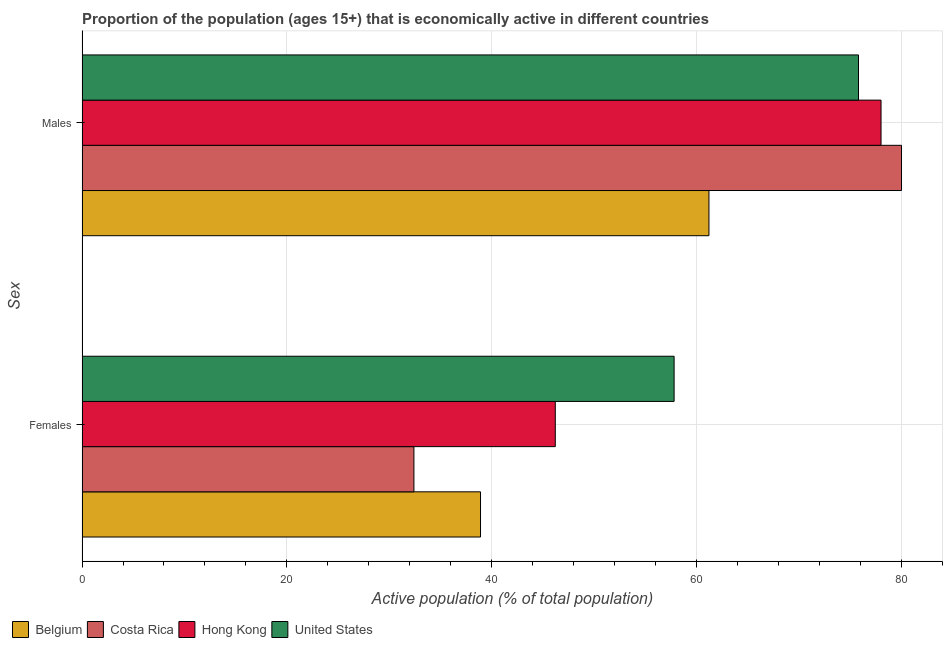How many bars are there on the 2nd tick from the top?
Provide a succinct answer. 4. What is the label of the 1st group of bars from the top?
Offer a terse response. Males. What is the percentage of economically active female population in Belgium?
Your answer should be compact. 38.9. Across all countries, what is the maximum percentage of economically active female population?
Your response must be concise. 57.8. Across all countries, what is the minimum percentage of economically active male population?
Your answer should be very brief. 61.2. What is the total percentage of economically active male population in the graph?
Offer a terse response. 295. What is the difference between the percentage of economically active female population in Hong Kong and that in United States?
Provide a short and direct response. -11.6. What is the difference between the percentage of economically active male population in Belgium and the percentage of economically active female population in Costa Rica?
Ensure brevity in your answer.  28.8. What is the average percentage of economically active male population per country?
Your answer should be very brief. 73.75. What is the difference between the percentage of economically active female population and percentage of economically active male population in Costa Rica?
Your answer should be very brief. -47.6. In how many countries, is the percentage of economically active male population greater than 24 %?
Ensure brevity in your answer.  4. What is the ratio of the percentage of economically active female population in Costa Rica to that in Belgium?
Give a very brief answer. 0.83. In how many countries, is the percentage of economically active male population greater than the average percentage of economically active male population taken over all countries?
Provide a succinct answer. 3. What does the 2nd bar from the top in Males represents?
Offer a terse response. Hong Kong. How many countries are there in the graph?
Make the answer very short. 4. What is the difference between two consecutive major ticks on the X-axis?
Provide a short and direct response. 20. Are the values on the major ticks of X-axis written in scientific E-notation?
Offer a very short reply. No. Does the graph contain grids?
Make the answer very short. Yes. Where does the legend appear in the graph?
Provide a succinct answer. Bottom left. How are the legend labels stacked?
Give a very brief answer. Horizontal. What is the title of the graph?
Provide a succinct answer. Proportion of the population (ages 15+) that is economically active in different countries. What is the label or title of the X-axis?
Offer a very short reply. Active population (% of total population). What is the label or title of the Y-axis?
Give a very brief answer. Sex. What is the Active population (% of total population) in Belgium in Females?
Offer a terse response. 38.9. What is the Active population (% of total population) in Costa Rica in Females?
Provide a short and direct response. 32.4. What is the Active population (% of total population) of Hong Kong in Females?
Your response must be concise. 46.2. What is the Active population (% of total population) of United States in Females?
Keep it short and to the point. 57.8. What is the Active population (% of total population) of Belgium in Males?
Your answer should be very brief. 61.2. What is the Active population (% of total population) of United States in Males?
Offer a very short reply. 75.8. Across all Sex, what is the maximum Active population (% of total population) in Belgium?
Offer a very short reply. 61.2. Across all Sex, what is the maximum Active population (% of total population) of Costa Rica?
Your answer should be compact. 80. Across all Sex, what is the maximum Active population (% of total population) in Hong Kong?
Your response must be concise. 78. Across all Sex, what is the maximum Active population (% of total population) in United States?
Provide a succinct answer. 75.8. Across all Sex, what is the minimum Active population (% of total population) in Belgium?
Give a very brief answer. 38.9. Across all Sex, what is the minimum Active population (% of total population) of Costa Rica?
Offer a very short reply. 32.4. Across all Sex, what is the minimum Active population (% of total population) of Hong Kong?
Your answer should be compact. 46.2. Across all Sex, what is the minimum Active population (% of total population) of United States?
Keep it short and to the point. 57.8. What is the total Active population (% of total population) of Belgium in the graph?
Provide a short and direct response. 100.1. What is the total Active population (% of total population) in Costa Rica in the graph?
Offer a terse response. 112.4. What is the total Active population (% of total population) of Hong Kong in the graph?
Make the answer very short. 124.2. What is the total Active population (% of total population) in United States in the graph?
Provide a short and direct response. 133.6. What is the difference between the Active population (% of total population) of Belgium in Females and that in Males?
Your response must be concise. -22.3. What is the difference between the Active population (% of total population) in Costa Rica in Females and that in Males?
Ensure brevity in your answer.  -47.6. What is the difference between the Active population (% of total population) of Hong Kong in Females and that in Males?
Offer a very short reply. -31.8. What is the difference between the Active population (% of total population) in Belgium in Females and the Active population (% of total population) in Costa Rica in Males?
Your answer should be compact. -41.1. What is the difference between the Active population (% of total population) of Belgium in Females and the Active population (% of total population) of Hong Kong in Males?
Make the answer very short. -39.1. What is the difference between the Active population (% of total population) of Belgium in Females and the Active population (% of total population) of United States in Males?
Your response must be concise. -36.9. What is the difference between the Active population (% of total population) in Costa Rica in Females and the Active population (% of total population) in Hong Kong in Males?
Provide a short and direct response. -45.6. What is the difference between the Active population (% of total population) in Costa Rica in Females and the Active population (% of total population) in United States in Males?
Offer a terse response. -43.4. What is the difference between the Active population (% of total population) of Hong Kong in Females and the Active population (% of total population) of United States in Males?
Give a very brief answer. -29.6. What is the average Active population (% of total population) of Belgium per Sex?
Offer a terse response. 50.05. What is the average Active population (% of total population) in Costa Rica per Sex?
Your answer should be very brief. 56.2. What is the average Active population (% of total population) of Hong Kong per Sex?
Offer a very short reply. 62.1. What is the average Active population (% of total population) in United States per Sex?
Give a very brief answer. 66.8. What is the difference between the Active population (% of total population) of Belgium and Active population (% of total population) of United States in Females?
Your answer should be compact. -18.9. What is the difference between the Active population (% of total population) in Costa Rica and Active population (% of total population) in United States in Females?
Your answer should be compact. -25.4. What is the difference between the Active population (% of total population) in Hong Kong and Active population (% of total population) in United States in Females?
Ensure brevity in your answer.  -11.6. What is the difference between the Active population (% of total population) of Belgium and Active population (% of total population) of Costa Rica in Males?
Offer a very short reply. -18.8. What is the difference between the Active population (% of total population) of Belgium and Active population (% of total population) of Hong Kong in Males?
Your answer should be compact. -16.8. What is the difference between the Active population (% of total population) in Belgium and Active population (% of total population) in United States in Males?
Make the answer very short. -14.6. What is the difference between the Active population (% of total population) in Costa Rica and Active population (% of total population) in Hong Kong in Males?
Make the answer very short. 2. What is the difference between the Active population (% of total population) in Costa Rica and Active population (% of total population) in United States in Males?
Ensure brevity in your answer.  4.2. What is the difference between the Active population (% of total population) of Hong Kong and Active population (% of total population) of United States in Males?
Offer a terse response. 2.2. What is the ratio of the Active population (% of total population) in Belgium in Females to that in Males?
Offer a terse response. 0.64. What is the ratio of the Active population (% of total population) of Costa Rica in Females to that in Males?
Give a very brief answer. 0.41. What is the ratio of the Active population (% of total population) of Hong Kong in Females to that in Males?
Offer a very short reply. 0.59. What is the ratio of the Active population (% of total population) of United States in Females to that in Males?
Your answer should be very brief. 0.76. What is the difference between the highest and the second highest Active population (% of total population) of Belgium?
Your answer should be very brief. 22.3. What is the difference between the highest and the second highest Active population (% of total population) of Costa Rica?
Your answer should be very brief. 47.6. What is the difference between the highest and the second highest Active population (% of total population) of Hong Kong?
Make the answer very short. 31.8. What is the difference between the highest and the lowest Active population (% of total population) of Belgium?
Keep it short and to the point. 22.3. What is the difference between the highest and the lowest Active population (% of total population) of Costa Rica?
Provide a succinct answer. 47.6. What is the difference between the highest and the lowest Active population (% of total population) in Hong Kong?
Keep it short and to the point. 31.8. What is the difference between the highest and the lowest Active population (% of total population) in United States?
Your answer should be very brief. 18. 